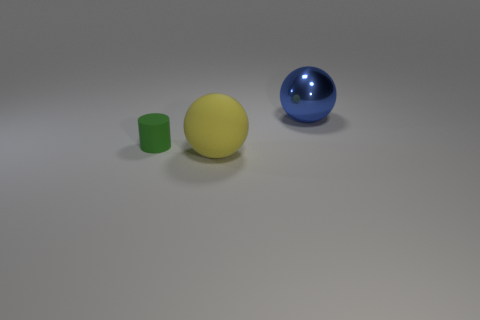Add 3 tiny gray shiny objects. How many objects exist? 6 Subtract all balls. How many objects are left? 1 Add 1 tiny matte cylinders. How many tiny matte cylinders are left? 2 Add 1 small cyan shiny cubes. How many small cyan shiny cubes exist? 1 Subtract 0 yellow cubes. How many objects are left? 3 Subtract all large rubber objects. Subtract all small cylinders. How many objects are left? 1 